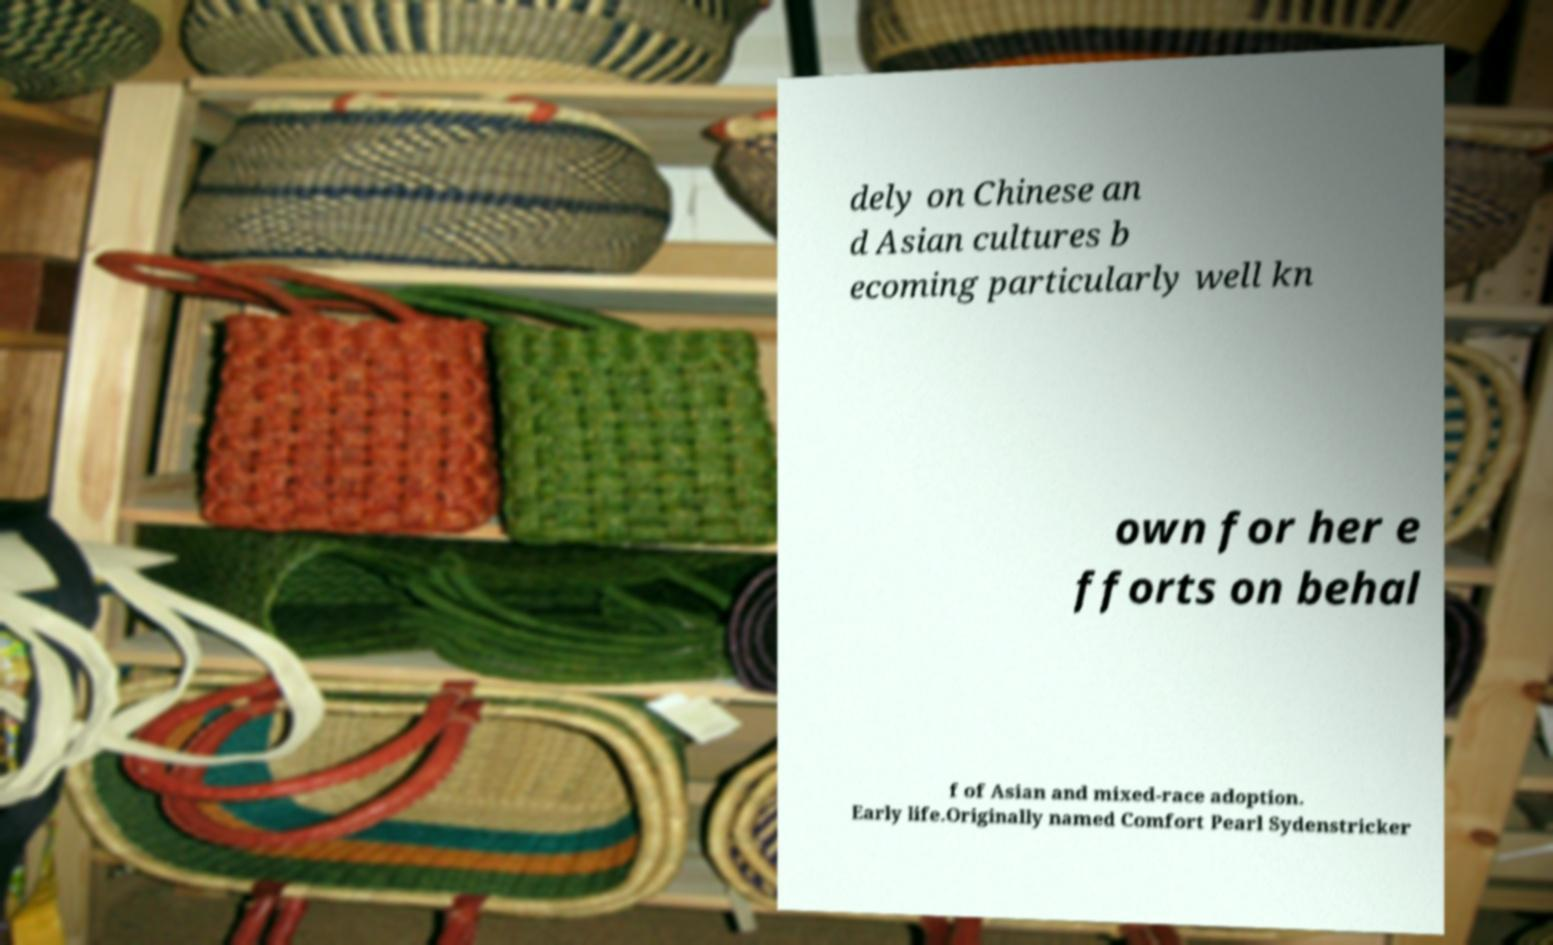For documentation purposes, I need the text within this image transcribed. Could you provide that? dely on Chinese an d Asian cultures b ecoming particularly well kn own for her e fforts on behal f of Asian and mixed-race adoption. Early life.Originally named Comfort Pearl Sydenstricker 